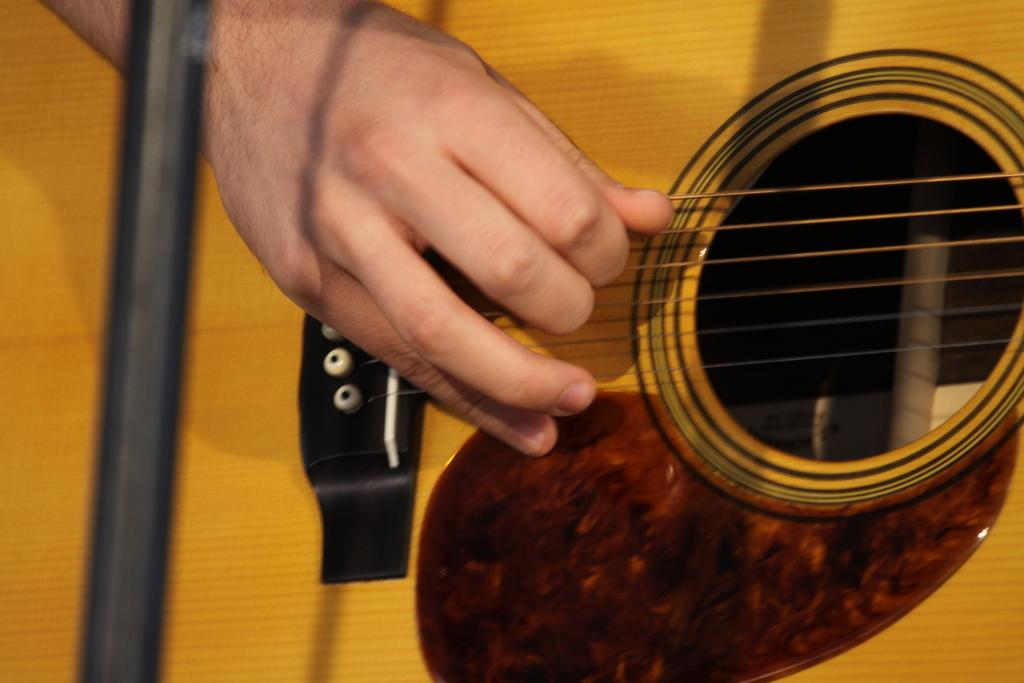What is the person in the image doing? The person is playing the guitar in the image. What part of the guitar is being touched by the person? There is a hand on a guitar in the image. What type of cattle can be seen grazing in the background of the image? There is no cattle present in the image; it only features a person playing the guitar. 